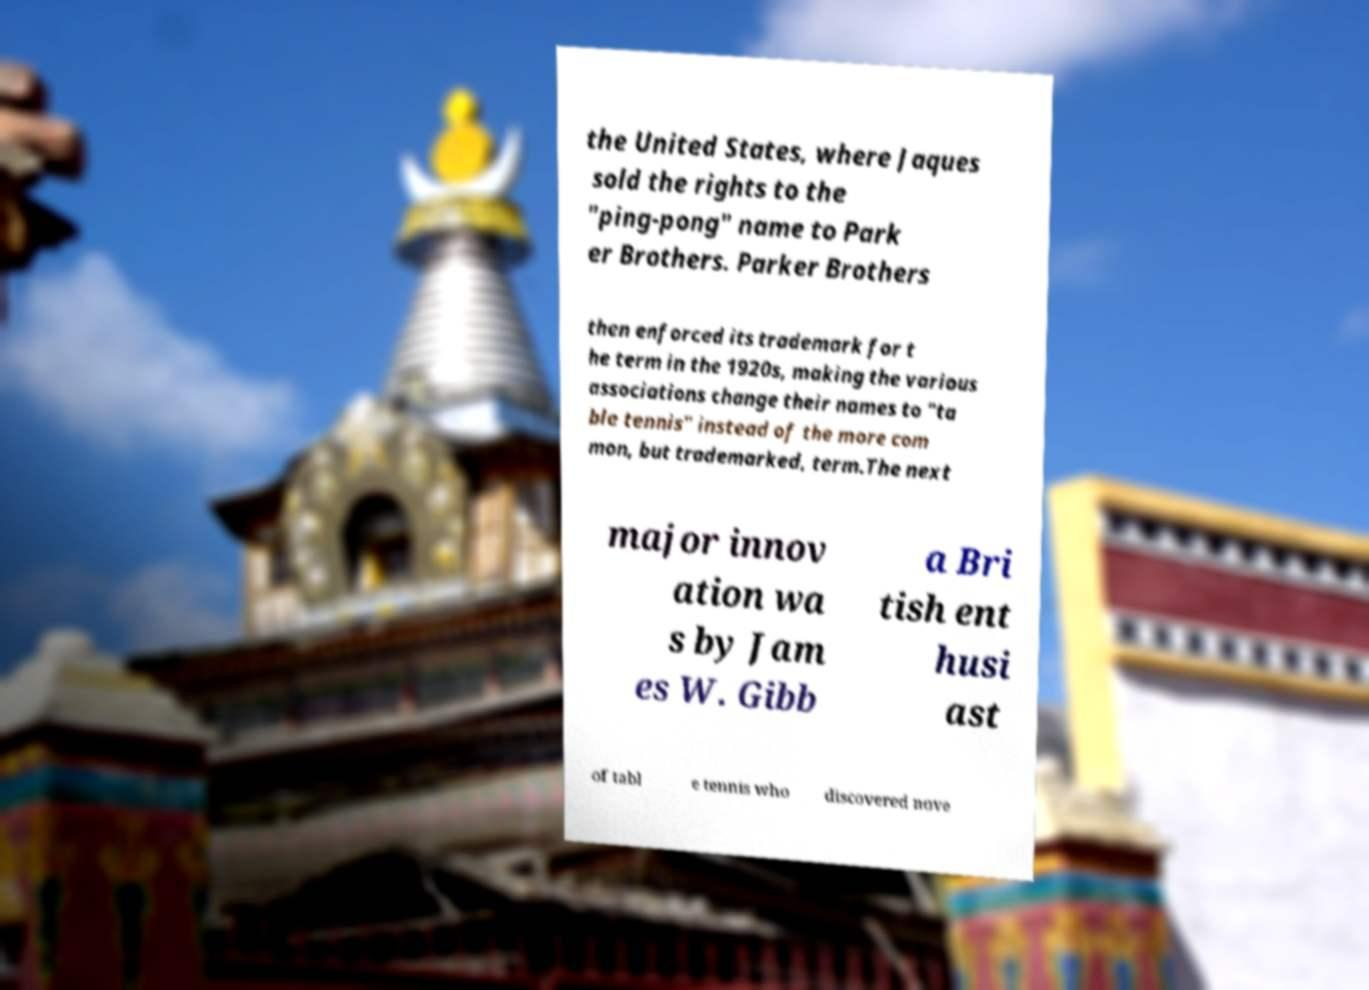Could you extract and type out the text from this image? the United States, where Jaques sold the rights to the "ping-pong" name to Park er Brothers. Parker Brothers then enforced its trademark for t he term in the 1920s, making the various associations change their names to "ta ble tennis" instead of the more com mon, but trademarked, term.The next major innov ation wa s by Jam es W. Gibb a Bri tish ent husi ast of tabl e tennis who discovered nove 